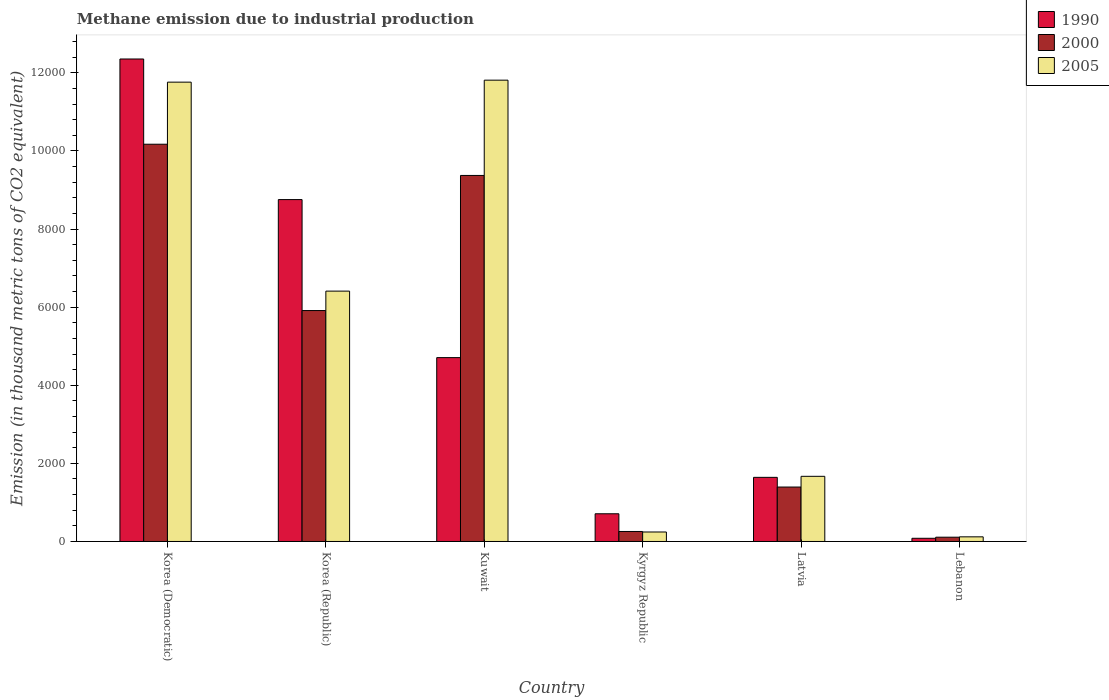Are the number of bars per tick equal to the number of legend labels?
Offer a very short reply. Yes. How many bars are there on the 5th tick from the left?
Your answer should be compact. 3. How many bars are there on the 6th tick from the right?
Your response must be concise. 3. What is the label of the 6th group of bars from the left?
Provide a succinct answer. Lebanon. What is the amount of methane emitted in 2005 in Kyrgyz Republic?
Keep it short and to the point. 242.8. Across all countries, what is the maximum amount of methane emitted in 2000?
Your answer should be very brief. 1.02e+04. Across all countries, what is the minimum amount of methane emitted in 2000?
Make the answer very short. 109.7. In which country was the amount of methane emitted in 2000 maximum?
Your answer should be compact. Korea (Democratic). In which country was the amount of methane emitted in 2005 minimum?
Provide a succinct answer. Lebanon. What is the total amount of methane emitted in 1990 in the graph?
Your answer should be very brief. 2.82e+04. What is the difference between the amount of methane emitted in 2000 in Kyrgyz Republic and that in Latvia?
Make the answer very short. -1137.9. What is the difference between the amount of methane emitted in 1990 in Korea (Republic) and the amount of methane emitted in 2005 in Kyrgyz Republic?
Your answer should be very brief. 8511.4. What is the average amount of methane emitted in 1990 per country?
Ensure brevity in your answer.  4708.07. What is the difference between the amount of methane emitted of/in 1990 and amount of methane emitted of/in 2005 in Lebanon?
Give a very brief answer. -37.3. In how many countries, is the amount of methane emitted in 2005 greater than 8400 thousand metric tons?
Ensure brevity in your answer.  2. What is the ratio of the amount of methane emitted in 1990 in Korea (Democratic) to that in Korea (Republic)?
Offer a terse response. 1.41. Is the difference between the amount of methane emitted in 1990 in Latvia and Lebanon greater than the difference between the amount of methane emitted in 2005 in Latvia and Lebanon?
Keep it short and to the point. Yes. What is the difference between the highest and the second highest amount of methane emitted in 2005?
Your answer should be very brief. 5350.6. What is the difference between the highest and the lowest amount of methane emitted in 2005?
Offer a very short reply. 1.17e+04. Is the sum of the amount of methane emitted in 2005 in Korea (Republic) and Kyrgyz Republic greater than the maximum amount of methane emitted in 1990 across all countries?
Make the answer very short. No. What does the 2nd bar from the left in Lebanon represents?
Make the answer very short. 2000. How many bars are there?
Provide a short and direct response. 18. Are all the bars in the graph horizontal?
Make the answer very short. No. What is the difference between two consecutive major ticks on the Y-axis?
Keep it short and to the point. 2000. Does the graph contain any zero values?
Provide a short and direct response. No. Does the graph contain grids?
Your answer should be compact. No. Where does the legend appear in the graph?
Keep it short and to the point. Top right. How are the legend labels stacked?
Offer a very short reply. Vertical. What is the title of the graph?
Ensure brevity in your answer.  Methane emission due to industrial production. Does "1999" appear as one of the legend labels in the graph?
Provide a short and direct response. No. What is the label or title of the Y-axis?
Your answer should be very brief. Emission (in thousand metric tons of CO2 equivalent). What is the Emission (in thousand metric tons of CO2 equivalent) of 1990 in Korea (Democratic)?
Ensure brevity in your answer.  1.24e+04. What is the Emission (in thousand metric tons of CO2 equivalent) of 2000 in Korea (Democratic)?
Give a very brief answer. 1.02e+04. What is the Emission (in thousand metric tons of CO2 equivalent) in 2005 in Korea (Democratic)?
Make the answer very short. 1.18e+04. What is the Emission (in thousand metric tons of CO2 equivalent) of 1990 in Korea (Republic)?
Ensure brevity in your answer.  8754.2. What is the Emission (in thousand metric tons of CO2 equivalent) in 2000 in Korea (Republic)?
Offer a very short reply. 5912.8. What is the Emission (in thousand metric tons of CO2 equivalent) in 2005 in Korea (Republic)?
Ensure brevity in your answer.  6410.4. What is the Emission (in thousand metric tons of CO2 equivalent) in 1990 in Kuwait?
Your answer should be compact. 4707.5. What is the Emission (in thousand metric tons of CO2 equivalent) in 2000 in Kuwait?
Keep it short and to the point. 9372. What is the Emission (in thousand metric tons of CO2 equivalent) of 2005 in Kuwait?
Offer a very short reply. 1.18e+04. What is the Emission (in thousand metric tons of CO2 equivalent) of 1990 in Kyrgyz Republic?
Make the answer very short. 709.3. What is the Emission (in thousand metric tons of CO2 equivalent) of 2000 in Kyrgyz Republic?
Keep it short and to the point. 255.9. What is the Emission (in thousand metric tons of CO2 equivalent) of 2005 in Kyrgyz Republic?
Provide a short and direct response. 242.8. What is the Emission (in thousand metric tons of CO2 equivalent) of 1990 in Latvia?
Your answer should be compact. 1642. What is the Emission (in thousand metric tons of CO2 equivalent) of 2000 in Latvia?
Make the answer very short. 1393.8. What is the Emission (in thousand metric tons of CO2 equivalent) in 2005 in Latvia?
Your answer should be compact. 1668.3. What is the Emission (in thousand metric tons of CO2 equivalent) of 1990 in Lebanon?
Your response must be concise. 81.7. What is the Emission (in thousand metric tons of CO2 equivalent) of 2000 in Lebanon?
Provide a short and direct response. 109.7. What is the Emission (in thousand metric tons of CO2 equivalent) of 2005 in Lebanon?
Offer a terse response. 119. Across all countries, what is the maximum Emission (in thousand metric tons of CO2 equivalent) of 1990?
Ensure brevity in your answer.  1.24e+04. Across all countries, what is the maximum Emission (in thousand metric tons of CO2 equivalent) of 2000?
Give a very brief answer. 1.02e+04. Across all countries, what is the maximum Emission (in thousand metric tons of CO2 equivalent) of 2005?
Ensure brevity in your answer.  1.18e+04. Across all countries, what is the minimum Emission (in thousand metric tons of CO2 equivalent) of 1990?
Offer a very short reply. 81.7. Across all countries, what is the minimum Emission (in thousand metric tons of CO2 equivalent) in 2000?
Keep it short and to the point. 109.7. Across all countries, what is the minimum Emission (in thousand metric tons of CO2 equivalent) of 2005?
Make the answer very short. 119. What is the total Emission (in thousand metric tons of CO2 equivalent) in 1990 in the graph?
Provide a short and direct response. 2.82e+04. What is the total Emission (in thousand metric tons of CO2 equivalent) in 2000 in the graph?
Make the answer very short. 2.72e+04. What is the total Emission (in thousand metric tons of CO2 equivalent) of 2005 in the graph?
Your answer should be very brief. 3.20e+04. What is the difference between the Emission (in thousand metric tons of CO2 equivalent) of 1990 in Korea (Democratic) and that in Korea (Republic)?
Make the answer very short. 3599.5. What is the difference between the Emission (in thousand metric tons of CO2 equivalent) in 2000 in Korea (Democratic) and that in Korea (Republic)?
Your response must be concise. 4258.8. What is the difference between the Emission (in thousand metric tons of CO2 equivalent) of 2005 in Korea (Democratic) and that in Korea (Republic)?
Give a very brief answer. 5350.6. What is the difference between the Emission (in thousand metric tons of CO2 equivalent) of 1990 in Korea (Democratic) and that in Kuwait?
Ensure brevity in your answer.  7646.2. What is the difference between the Emission (in thousand metric tons of CO2 equivalent) of 2000 in Korea (Democratic) and that in Kuwait?
Provide a short and direct response. 799.6. What is the difference between the Emission (in thousand metric tons of CO2 equivalent) in 2005 in Korea (Democratic) and that in Kuwait?
Give a very brief answer. -50.7. What is the difference between the Emission (in thousand metric tons of CO2 equivalent) of 1990 in Korea (Democratic) and that in Kyrgyz Republic?
Offer a very short reply. 1.16e+04. What is the difference between the Emission (in thousand metric tons of CO2 equivalent) of 2000 in Korea (Democratic) and that in Kyrgyz Republic?
Your answer should be very brief. 9915.7. What is the difference between the Emission (in thousand metric tons of CO2 equivalent) in 2005 in Korea (Democratic) and that in Kyrgyz Republic?
Provide a succinct answer. 1.15e+04. What is the difference between the Emission (in thousand metric tons of CO2 equivalent) in 1990 in Korea (Democratic) and that in Latvia?
Offer a terse response. 1.07e+04. What is the difference between the Emission (in thousand metric tons of CO2 equivalent) in 2000 in Korea (Democratic) and that in Latvia?
Offer a terse response. 8777.8. What is the difference between the Emission (in thousand metric tons of CO2 equivalent) in 2005 in Korea (Democratic) and that in Latvia?
Keep it short and to the point. 1.01e+04. What is the difference between the Emission (in thousand metric tons of CO2 equivalent) in 1990 in Korea (Democratic) and that in Lebanon?
Your answer should be very brief. 1.23e+04. What is the difference between the Emission (in thousand metric tons of CO2 equivalent) of 2000 in Korea (Democratic) and that in Lebanon?
Your answer should be compact. 1.01e+04. What is the difference between the Emission (in thousand metric tons of CO2 equivalent) of 2005 in Korea (Democratic) and that in Lebanon?
Make the answer very short. 1.16e+04. What is the difference between the Emission (in thousand metric tons of CO2 equivalent) of 1990 in Korea (Republic) and that in Kuwait?
Give a very brief answer. 4046.7. What is the difference between the Emission (in thousand metric tons of CO2 equivalent) of 2000 in Korea (Republic) and that in Kuwait?
Keep it short and to the point. -3459.2. What is the difference between the Emission (in thousand metric tons of CO2 equivalent) in 2005 in Korea (Republic) and that in Kuwait?
Provide a short and direct response. -5401.3. What is the difference between the Emission (in thousand metric tons of CO2 equivalent) in 1990 in Korea (Republic) and that in Kyrgyz Republic?
Provide a succinct answer. 8044.9. What is the difference between the Emission (in thousand metric tons of CO2 equivalent) in 2000 in Korea (Republic) and that in Kyrgyz Republic?
Provide a succinct answer. 5656.9. What is the difference between the Emission (in thousand metric tons of CO2 equivalent) of 2005 in Korea (Republic) and that in Kyrgyz Republic?
Your answer should be very brief. 6167.6. What is the difference between the Emission (in thousand metric tons of CO2 equivalent) in 1990 in Korea (Republic) and that in Latvia?
Your response must be concise. 7112.2. What is the difference between the Emission (in thousand metric tons of CO2 equivalent) in 2000 in Korea (Republic) and that in Latvia?
Make the answer very short. 4519. What is the difference between the Emission (in thousand metric tons of CO2 equivalent) of 2005 in Korea (Republic) and that in Latvia?
Your answer should be compact. 4742.1. What is the difference between the Emission (in thousand metric tons of CO2 equivalent) of 1990 in Korea (Republic) and that in Lebanon?
Your answer should be very brief. 8672.5. What is the difference between the Emission (in thousand metric tons of CO2 equivalent) of 2000 in Korea (Republic) and that in Lebanon?
Your answer should be compact. 5803.1. What is the difference between the Emission (in thousand metric tons of CO2 equivalent) of 2005 in Korea (Republic) and that in Lebanon?
Your answer should be very brief. 6291.4. What is the difference between the Emission (in thousand metric tons of CO2 equivalent) of 1990 in Kuwait and that in Kyrgyz Republic?
Offer a terse response. 3998.2. What is the difference between the Emission (in thousand metric tons of CO2 equivalent) of 2000 in Kuwait and that in Kyrgyz Republic?
Offer a very short reply. 9116.1. What is the difference between the Emission (in thousand metric tons of CO2 equivalent) in 2005 in Kuwait and that in Kyrgyz Republic?
Keep it short and to the point. 1.16e+04. What is the difference between the Emission (in thousand metric tons of CO2 equivalent) in 1990 in Kuwait and that in Latvia?
Give a very brief answer. 3065.5. What is the difference between the Emission (in thousand metric tons of CO2 equivalent) of 2000 in Kuwait and that in Latvia?
Ensure brevity in your answer.  7978.2. What is the difference between the Emission (in thousand metric tons of CO2 equivalent) in 2005 in Kuwait and that in Latvia?
Provide a succinct answer. 1.01e+04. What is the difference between the Emission (in thousand metric tons of CO2 equivalent) of 1990 in Kuwait and that in Lebanon?
Make the answer very short. 4625.8. What is the difference between the Emission (in thousand metric tons of CO2 equivalent) in 2000 in Kuwait and that in Lebanon?
Make the answer very short. 9262.3. What is the difference between the Emission (in thousand metric tons of CO2 equivalent) in 2005 in Kuwait and that in Lebanon?
Keep it short and to the point. 1.17e+04. What is the difference between the Emission (in thousand metric tons of CO2 equivalent) of 1990 in Kyrgyz Republic and that in Latvia?
Give a very brief answer. -932.7. What is the difference between the Emission (in thousand metric tons of CO2 equivalent) of 2000 in Kyrgyz Republic and that in Latvia?
Provide a succinct answer. -1137.9. What is the difference between the Emission (in thousand metric tons of CO2 equivalent) of 2005 in Kyrgyz Republic and that in Latvia?
Provide a short and direct response. -1425.5. What is the difference between the Emission (in thousand metric tons of CO2 equivalent) of 1990 in Kyrgyz Republic and that in Lebanon?
Provide a succinct answer. 627.6. What is the difference between the Emission (in thousand metric tons of CO2 equivalent) in 2000 in Kyrgyz Republic and that in Lebanon?
Provide a short and direct response. 146.2. What is the difference between the Emission (in thousand metric tons of CO2 equivalent) of 2005 in Kyrgyz Republic and that in Lebanon?
Offer a very short reply. 123.8. What is the difference between the Emission (in thousand metric tons of CO2 equivalent) in 1990 in Latvia and that in Lebanon?
Provide a succinct answer. 1560.3. What is the difference between the Emission (in thousand metric tons of CO2 equivalent) of 2000 in Latvia and that in Lebanon?
Provide a succinct answer. 1284.1. What is the difference between the Emission (in thousand metric tons of CO2 equivalent) in 2005 in Latvia and that in Lebanon?
Offer a terse response. 1549.3. What is the difference between the Emission (in thousand metric tons of CO2 equivalent) in 1990 in Korea (Democratic) and the Emission (in thousand metric tons of CO2 equivalent) in 2000 in Korea (Republic)?
Provide a succinct answer. 6440.9. What is the difference between the Emission (in thousand metric tons of CO2 equivalent) of 1990 in Korea (Democratic) and the Emission (in thousand metric tons of CO2 equivalent) of 2005 in Korea (Republic)?
Offer a terse response. 5943.3. What is the difference between the Emission (in thousand metric tons of CO2 equivalent) of 2000 in Korea (Democratic) and the Emission (in thousand metric tons of CO2 equivalent) of 2005 in Korea (Republic)?
Your answer should be very brief. 3761.2. What is the difference between the Emission (in thousand metric tons of CO2 equivalent) in 1990 in Korea (Democratic) and the Emission (in thousand metric tons of CO2 equivalent) in 2000 in Kuwait?
Your answer should be compact. 2981.7. What is the difference between the Emission (in thousand metric tons of CO2 equivalent) of 1990 in Korea (Democratic) and the Emission (in thousand metric tons of CO2 equivalent) of 2005 in Kuwait?
Your response must be concise. 542. What is the difference between the Emission (in thousand metric tons of CO2 equivalent) of 2000 in Korea (Democratic) and the Emission (in thousand metric tons of CO2 equivalent) of 2005 in Kuwait?
Your answer should be very brief. -1640.1. What is the difference between the Emission (in thousand metric tons of CO2 equivalent) of 1990 in Korea (Democratic) and the Emission (in thousand metric tons of CO2 equivalent) of 2000 in Kyrgyz Republic?
Provide a succinct answer. 1.21e+04. What is the difference between the Emission (in thousand metric tons of CO2 equivalent) in 1990 in Korea (Democratic) and the Emission (in thousand metric tons of CO2 equivalent) in 2005 in Kyrgyz Republic?
Provide a short and direct response. 1.21e+04. What is the difference between the Emission (in thousand metric tons of CO2 equivalent) in 2000 in Korea (Democratic) and the Emission (in thousand metric tons of CO2 equivalent) in 2005 in Kyrgyz Republic?
Give a very brief answer. 9928.8. What is the difference between the Emission (in thousand metric tons of CO2 equivalent) in 1990 in Korea (Democratic) and the Emission (in thousand metric tons of CO2 equivalent) in 2000 in Latvia?
Make the answer very short. 1.10e+04. What is the difference between the Emission (in thousand metric tons of CO2 equivalent) in 1990 in Korea (Democratic) and the Emission (in thousand metric tons of CO2 equivalent) in 2005 in Latvia?
Your answer should be very brief. 1.07e+04. What is the difference between the Emission (in thousand metric tons of CO2 equivalent) in 2000 in Korea (Democratic) and the Emission (in thousand metric tons of CO2 equivalent) in 2005 in Latvia?
Provide a short and direct response. 8503.3. What is the difference between the Emission (in thousand metric tons of CO2 equivalent) in 1990 in Korea (Democratic) and the Emission (in thousand metric tons of CO2 equivalent) in 2000 in Lebanon?
Your answer should be very brief. 1.22e+04. What is the difference between the Emission (in thousand metric tons of CO2 equivalent) in 1990 in Korea (Democratic) and the Emission (in thousand metric tons of CO2 equivalent) in 2005 in Lebanon?
Offer a very short reply. 1.22e+04. What is the difference between the Emission (in thousand metric tons of CO2 equivalent) in 2000 in Korea (Democratic) and the Emission (in thousand metric tons of CO2 equivalent) in 2005 in Lebanon?
Provide a succinct answer. 1.01e+04. What is the difference between the Emission (in thousand metric tons of CO2 equivalent) in 1990 in Korea (Republic) and the Emission (in thousand metric tons of CO2 equivalent) in 2000 in Kuwait?
Ensure brevity in your answer.  -617.8. What is the difference between the Emission (in thousand metric tons of CO2 equivalent) of 1990 in Korea (Republic) and the Emission (in thousand metric tons of CO2 equivalent) of 2005 in Kuwait?
Make the answer very short. -3057.5. What is the difference between the Emission (in thousand metric tons of CO2 equivalent) of 2000 in Korea (Republic) and the Emission (in thousand metric tons of CO2 equivalent) of 2005 in Kuwait?
Give a very brief answer. -5898.9. What is the difference between the Emission (in thousand metric tons of CO2 equivalent) in 1990 in Korea (Republic) and the Emission (in thousand metric tons of CO2 equivalent) in 2000 in Kyrgyz Republic?
Provide a short and direct response. 8498.3. What is the difference between the Emission (in thousand metric tons of CO2 equivalent) in 1990 in Korea (Republic) and the Emission (in thousand metric tons of CO2 equivalent) in 2005 in Kyrgyz Republic?
Give a very brief answer. 8511.4. What is the difference between the Emission (in thousand metric tons of CO2 equivalent) of 2000 in Korea (Republic) and the Emission (in thousand metric tons of CO2 equivalent) of 2005 in Kyrgyz Republic?
Your response must be concise. 5670. What is the difference between the Emission (in thousand metric tons of CO2 equivalent) of 1990 in Korea (Republic) and the Emission (in thousand metric tons of CO2 equivalent) of 2000 in Latvia?
Your answer should be compact. 7360.4. What is the difference between the Emission (in thousand metric tons of CO2 equivalent) of 1990 in Korea (Republic) and the Emission (in thousand metric tons of CO2 equivalent) of 2005 in Latvia?
Ensure brevity in your answer.  7085.9. What is the difference between the Emission (in thousand metric tons of CO2 equivalent) of 2000 in Korea (Republic) and the Emission (in thousand metric tons of CO2 equivalent) of 2005 in Latvia?
Keep it short and to the point. 4244.5. What is the difference between the Emission (in thousand metric tons of CO2 equivalent) in 1990 in Korea (Republic) and the Emission (in thousand metric tons of CO2 equivalent) in 2000 in Lebanon?
Provide a short and direct response. 8644.5. What is the difference between the Emission (in thousand metric tons of CO2 equivalent) of 1990 in Korea (Republic) and the Emission (in thousand metric tons of CO2 equivalent) of 2005 in Lebanon?
Provide a succinct answer. 8635.2. What is the difference between the Emission (in thousand metric tons of CO2 equivalent) of 2000 in Korea (Republic) and the Emission (in thousand metric tons of CO2 equivalent) of 2005 in Lebanon?
Your answer should be very brief. 5793.8. What is the difference between the Emission (in thousand metric tons of CO2 equivalent) in 1990 in Kuwait and the Emission (in thousand metric tons of CO2 equivalent) in 2000 in Kyrgyz Republic?
Offer a terse response. 4451.6. What is the difference between the Emission (in thousand metric tons of CO2 equivalent) of 1990 in Kuwait and the Emission (in thousand metric tons of CO2 equivalent) of 2005 in Kyrgyz Republic?
Offer a terse response. 4464.7. What is the difference between the Emission (in thousand metric tons of CO2 equivalent) in 2000 in Kuwait and the Emission (in thousand metric tons of CO2 equivalent) in 2005 in Kyrgyz Republic?
Provide a succinct answer. 9129.2. What is the difference between the Emission (in thousand metric tons of CO2 equivalent) of 1990 in Kuwait and the Emission (in thousand metric tons of CO2 equivalent) of 2000 in Latvia?
Provide a succinct answer. 3313.7. What is the difference between the Emission (in thousand metric tons of CO2 equivalent) of 1990 in Kuwait and the Emission (in thousand metric tons of CO2 equivalent) of 2005 in Latvia?
Offer a terse response. 3039.2. What is the difference between the Emission (in thousand metric tons of CO2 equivalent) of 2000 in Kuwait and the Emission (in thousand metric tons of CO2 equivalent) of 2005 in Latvia?
Give a very brief answer. 7703.7. What is the difference between the Emission (in thousand metric tons of CO2 equivalent) in 1990 in Kuwait and the Emission (in thousand metric tons of CO2 equivalent) in 2000 in Lebanon?
Give a very brief answer. 4597.8. What is the difference between the Emission (in thousand metric tons of CO2 equivalent) of 1990 in Kuwait and the Emission (in thousand metric tons of CO2 equivalent) of 2005 in Lebanon?
Offer a terse response. 4588.5. What is the difference between the Emission (in thousand metric tons of CO2 equivalent) in 2000 in Kuwait and the Emission (in thousand metric tons of CO2 equivalent) in 2005 in Lebanon?
Ensure brevity in your answer.  9253. What is the difference between the Emission (in thousand metric tons of CO2 equivalent) of 1990 in Kyrgyz Republic and the Emission (in thousand metric tons of CO2 equivalent) of 2000 in Latvia?
Ensure brevity in your answer.  -684.5. What is the difference between the Emission (in thousand metric tons of CO2 equivalent) of 1990 in Kyrgyz Republic and the Emission (in thousand metric tons of CO2 equivalent) of 2005 in Latvia?
Give a very brief answer. -959. What is the difference between the Emission (in thousand metric tons of CO2 equivalent) of 2000 in Kyrgyz Republic and the Emission (in thousand metric tons of CO2 equivalent) of 2005 in Latvia?
Provide a short and direct response. -1412.4. What is the difference between the Emission (in thousand metric tons of CO2 equivalent) of 1990 in Kyrgyz Republic and the Emission (in thousand metric tons of CO2 equivalent) of 2000 in Lebanon?
Offer a terse response. 599.6. What is the difference between the Emission (in thousand metric tons of CO2 equivalent) in 1990 in Kyrgyz Republic and the Emission (in thousand metric tons of CO2 equivalent) in 2005 in Lebanon?
Make the answer very short. 590.3. What is the difference between the Emission (in thousand metric tons of CO2 equivalent) of 2000 in Kyrgyz Republic and the Emission (in thousand metric tons of CO2 equivalent) of 2005 in Lebanon?
Keep it short and to the point. 136.9. What is the difference between the Emission (in thousand metric tons of CO2 equivalent) of 1990 in Latvia and the Emission (in thousand metric tons of CO2 equivalent) of 2000 in Lebanon?
Keep it short and to the point. 1532.3. What is the difference between the Emission (in thousand metric tons of CO2 equivalent) in 1990 in Latvia and the Emission (in thousand metric tons of CO2 equivalent) in 2005 in Lebanon?
Keep it short and to the point. 1523. What is the difference between the Emission (in thousand metric tons of CO2 equivalent) of 2000 in Latvia and the Emission (in thousand metric tons of CO2 equivalent) of 2005 in Lebanon?
Your answer should be compact. 1274.8. What is the average Emission (in thousand metric tons of CO2 equivalent) in 1990 per country?
Give a very brief answer. 4708.07. What is the average Emission (in thousand metric tons of CO2 equivalent) in 2000 per country?
Make the answer very short. 4535.97. What is the average Emission (in thousand metric tons of CO2 equivalent) of 2005 per country?
Provide a succinct answer. 5335.53. What is the difference between the Emission (in thousand metric tons of CO2 equivalent) of 1990 and Emission (in thousand metric tons of CO2 equivalent) of 2000 in Korea (Democratic)?
Offer a very short reply. 2182.1. What is the difference between the Emission (in thousand metric tons of CO2 equivalent) of 1990 and Emission (in thousand metric tons of CO2 equivalent) of 2005 in Korea (Democratic)?
Offer a very short reply. 592.7. What is the difference between the Emission (in thousand metric tons of CO2 equivalent) in 2000 and Emission (in thousand metric tons of CO2 equivalent) in 2005 in Korea (Democratic)?
Your answer should be very brief. -1589.4. What is the difference between the Emission (in thousand metric tons of CO2 equivalent) of 1990 and Emission (in thousand metric tons of CO2 equivalent) of 2000 in Korea (Republic)?
Offer a very short reply. 2841.4. What is the difference between the Emission (in thousand metric tons of CO2 equivalent) of 1990 and Emission (in thousand metric tons of CO2 equivalent) of 2005 in Korea (Republic)?
Provide a short and direct response. 2343.8. What is the difference between the Emission (in thousand metric tons of CO2 equivalent) of 2000 and Emission (in thousand metric tons of CO2 equivalent) of 2005 in Korea (Republic)?
Give a very brief answer. -497.6. What is the difference between the Emission (in thousand metric tons of CO2 equivalent) of 1990 and Emission (in thousand metric tons of CO2 equivalent) of 2000 in Kuwait?
Your answer should be very brief. -4664.5. What is the difference between the Emission (in thousand metric tons of CO2 equivalent) of 1990 and Emission (in thousand metric tons of CO2 equivalent) of 2005 in Kuwait?
Your answer should be compact. -7104.2. What is the difference between the Emission (in thousand metric tons of CO2 equivalent) of 2000 and Emission (in thousand metric tons of CO2 equivalent) of 2005 in Kuwait?
Keep it short and to the point. -2439.7. What is the difference between the Emission (in thousand metric tons of CO2 equivalent) of 1990 and Emission (in thousand metric tons of CO2 equivalent) of 2000 in Kyrgyz Republic?
Your answer should be compact. 453.4. What is the difference between the Emission (in thousand metric tons of CO2 equivalent) of 1990 and Emission (in thousand metric tons of CO2 equivalent) of 2005 in Kyrgyz Republic?
Keep it short and to the point. 466.5. What is the difference between the Emission (in thousand metric tons of CO2 equivalent) of 1990 and Emission (in thousand metric tons of CO2 equivalent) of 2000 in Latvia?
Keep it short and to the point. 248.2. What is the difference between the Emission (in thousand metric tons of CO2 equivalent) in 1990 and Emission (in thousand metric tons of CO2 equivalent) in 2005 in Latvia?
Make the answer very short. -26.3. What is the difference between the Emission (in thousand metric tons of CO2 equivalent) of 2000 and Emission (in thousand metric tons of CO2 equivalent) of 2005 in Latvia?
Your answer should be very brief. -274.5. What is the difference between the Emission (in thousand metric tons of CO2 equivalent) of 1990 and Emission (in thousand metric tons of CO2 equivalent) of 2000 in Lebanon?
Provide a succinct answer. -28. What is the difference between the Emission (in thousand metric tons of CO2 equivalent) in 1990 and Emission (in thousand metric tons of CO2 equivalent) in 2005 in Lebanon?
Offer a terse response. -37.3. What is the ratio of the Emission (in thousand metric tons of CO2 equivalent) in 1990 in Korea (Democratic) to that in Korea (Republic)?
Ensure brevity in your answer.  1.41. What is the ratio of the Emission (in thousand metric tons of CO2 equivalent) in 2000 in Korea (Democratic) to that in Korea (Republic)?
Your answer should be very brief. 1.72. What is the ratio of the Emission (in thousand metric tons of CO2 equivalent) in 2005 in Korea (Democratic) to that in Korea (Republic)?
Ensure brevity in your answer.  1.83. What is the ratio of the Emission (in thousand metric tons of CO2 equivalent) of 1990 in Korea (Democratic) to that in Kuwait?
Give a very brief answer. 2.62. What is the ratio of the Emission (in thousand metric tons of CO2 equivalent) of 2000 in Korea (Democratic) to that in Kuwait?
Give a very brief answer. 1.09. What is the ratio of the Emission (in thousand metric tons of CO2 equivalent) of 1990 in Korea (Democratic) to that in Kyrgyz Republic?
Ensure brevity in your answer.  17.42. What is the ratio of the Emission (in thousand metric tons of CO2 equivalent) in 2000 in Korea (Democratic) to that in Kyrgyz Republic?
Offer a very short reply. 39.75. What is the ratio of the Emission (in thousand metric tons of CO2 equivalent) of 2005 in Korea (Democratic) to that in Kyrgyz Republic?
Your answer should be very brief. 48.44. What is the ratio of the Emission (in thousand metric tons of CO2 equivalent) of 1990 in Korea (Democratic) to that in Latvia?
Your answer should be very brief. 7.52. What is the ratio of the Emission (in thousand metric tons of CO2 equivalent) in 2000 in Korea (Democratic) to that in Latvia?
Make the answer very short. 7.3. What is the ratio of the Emission (in thousand metric tons of CO2 equivalent) of 2005 in Korea (Democratic) to that in Latvia?
Give a very brief answer. 7.05. What is the ratio of the Emission (in thousand metric tons of CO2 equivalent) of 1990 in Korea (Democratic) to that in Lebanon?
Your response must be concise. 151.21. What is the ratio of the Emission (in thousand metric tons of CO2 equivalent) in 2000 in Korea (Democratic) to that in Lebanon?
Your answer should be very brief. 92.72. What is the ratio of the Emission (in thousand metric tons of CO2 equivalent) of 2005 in Korea (Democratic) to that in Lebanon?
Provide a short and direct response. 98.83. What is the ratio of the Emission (in thousand metric tons of CO2 equivalent) of 1990 in Korea (Republic) to that in Kuwait?
Your response must be concise. 1.86. What is the ratio of the Emission (in thousand metric tons of CO2 equivalent) in 2000 in Korea (Republic) to that in Kuwait?
Your answer should be very brief. 0.63. What is the ratio of the Emission (in thousand metric tons of CO2 equivalent) in 2005 in Korea (Republic) to that in Kuwait?
Ensure brevity in your answer.  0.54. What is the ratio of the Emission (in thousand metric tons of CO2 equivalent) in 1990 in Korea (Republic) to that in Kyrgyz Republic?
Your answer should be very brief. 12.34. What is the ratio of the Emission (in thousand metric tons of CO2 equivalent) in 2000 in Korea (Republic) to that in Kyrgyz Republic?
Your answer should be very brief. 23.11. What is the ratio of the Emission (in thousand metric tons of CO2 equivalent) in 2005 in Korea (Republic) to that in Kyrgyz Republic?
Ensure brevity in your answer.  26.4. What is the ratio of the Emission (in thousand metric tons of CO2 equivalent) of 1990 in Korea (Republic) to that in Latvia?
Your answer should be very brief. 5.33. What is the ratio of the Emission (in thousand metric tons of CO2 equivalent) of 2000 in Korea (Republic) to that in Latvia?
Your answer should be very brief. 4.24. What is the ratio of the Emission (in thousand metric tons of CO2 equivalent) of 2005 in Korea (Republic) to that in Latvia?
Offer a very short reply. 3.84. What is the ratio of the Emission (in thousand metric tons of CO2 equivalent) in 1990 in Korea (Republic) to that in Lebanon?
Your answer should be compact. 107.15. What is the ratio of the Emission (in thousand metric tons of CO2 equivalent) in 2000 in Korea (Republic) to that in Lebanon?
Give a very brief answer. 53.9. What is the ratio of the Emission (in thousand metric tons of CO2 equivalent) in 2005 in Korea (Republic) to that in Lebanon?
Offer a terse response. 53.87. What is the ratio of the Emission (in thousand metric tons of CO2 equivalent) in 1990 in Kuwait to that in Kyrgyz Republic?
Offer a very short reply. 6.64. What is the ratio of the Emission (in thousand metric tons of CO2 equivalent) of 2000 in Kuwait to that in Kyrgyz Republic?
Your response must be concise. 36.62. What is the ratio of the Emission (in thousand metric tons of CO2 equivalent) of 2005 in Kuwait to that in Kyrgyz Republic?
Make the answer very short. 48.65. What is the ratio of the Emission (in thousand metric tons of CO2 equivalent) of 1990 in Kuwait to that in Latvia?
Your response must be concise. 2.87. What is the ratio of the Emission (in thousand metric tons of CO2 equivalent) of 2000 in Kuwait to that in Latvia?
Keep it short and to the point. 6.72. What is the ratio of the Emission (in thousand metric tons of CO2 equivalent) in 2005 in Kuwait to that in Latvia?
Provide a short and direct response. 7.08. What is the ratio of the Emission (in thousand metric tons of CO2 equivalent) in 1990 in Kuwait to that in Lebanon?
Give a very brief answer. 57.62. What is the ratio of the Emission (in thousand metric tons of CO2 equivalent) of 2000 in Kuwait to that in Lebanon?
Provide a short and direct response. 85.43. What is the ratio of the Emission (in thousand metric tons of CO2 equivalent) of 2005 in Kuwait to that in Lebanon?
Provide a succinct answer. 99.26. What is the ratio of the Emission (in thousand metric tons of CO2 equivalent) of 1990 in Kyrgyz Republic to that in Latvia?
Offer a very short reply. 0.43. What is the ratio of the Emission (in thousand metric tons of CO2 equivalent) in 2000 in Kyrgyz Republic to that in Latvia?
Your answer should be compact. 0.18. What is the ratio of the Emission (in thousand metric tons of CO2 equivalent) of 2005 in Kyrgyz Republic to that in Latvia?
Ensure brevity in your answer.  0.15. What is the ratio of the Emission (in thousand metric tons of CO2 equivalent) of 1990 in Kyrgyz Republic to that in Lebanon?
Provide a short and direct response. 8.68. What is the ratio of the Emission (in thousand metric tons of CO2 equivalent) of 2000 in Kyrgyz Republic to that in Lebanon?
Give a very brief answer. 2.33. What is the ratio of the Emission (in thousand metric tons of CO2 equivalent) of 2005 in Kyrgyz Republic to that in Lebanon?
Offer a very short reply. 2.04. What is the ratio of the Emission (in thousand metric tons of CO2 equivalent) of 1990 in Latvia to that in Lebanon?
Offer a terse response. 20.1. What is the ratio of the Emission (in thousand metric tons of CO2 equivalent) in 2000 in Latvia to that in Lebanon?
Offer a terse response. 12.71. What is the ratio of the Emission (in thousand metric tons of CO2 equivalent) in 2005 in Latvia to that in Lebanon?
Offer a very short reply. 14.02. What is the difference between the highest and the second highest Emission (in thousand metric tons of CO2 equivalent) of 1990?
Your response must be concise. 3599.5. What is the difference between the highest and the second highest Emission (in thousand metric tons of CO2 equivalent) of 2000?
Provide a succinct answer. 799.6. What is the difference between the highest and the second highest Emission (in thousand metric tons of CO2 equivalent) in 2005?
Give a very brief answer. 50.7. What is the difference between the highest and the lowest Emission (in thousand metric tons of CO2 equivalent) of 1990?
Your answer should be compact. 1.23e+04. What is the difference between the highest and the lowest Emission (in thousand metric tons of CO2 equivalent) in 2000?
Your answer should be very brief. 1.01e+04. What is the difference between the highest and the lowest Emission (in thousand metric tons of CO2 equivalent) of 2005?
Keep it short and to the point. 1.17e+04. 